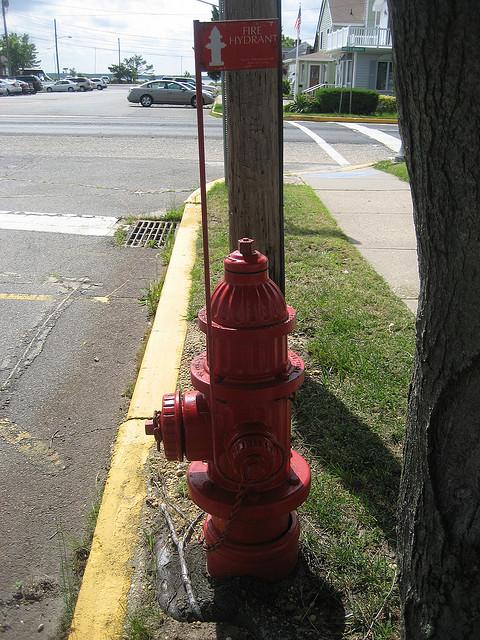Is there a tree next to the fire hydrant?
Be succinct. Yes. Where is the nearest crosswalk?
Quick response, please. At corner. What color is the fire hydrant?
Concise answer only. Red. 